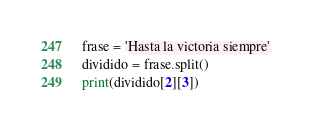Convert code to text. <code><loc_0><loc_0><loc_500><loc_500><_Python_>frase = 'Hasta la victoria siempre'
dividido = frase.split()
print(dividido[2][3])
</code> 